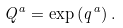<formula> <loc_0><loc_0><loc_500><loc_500>Q ^ { a } = \exp \left ( q ^ { a } \right ) .</formula> 